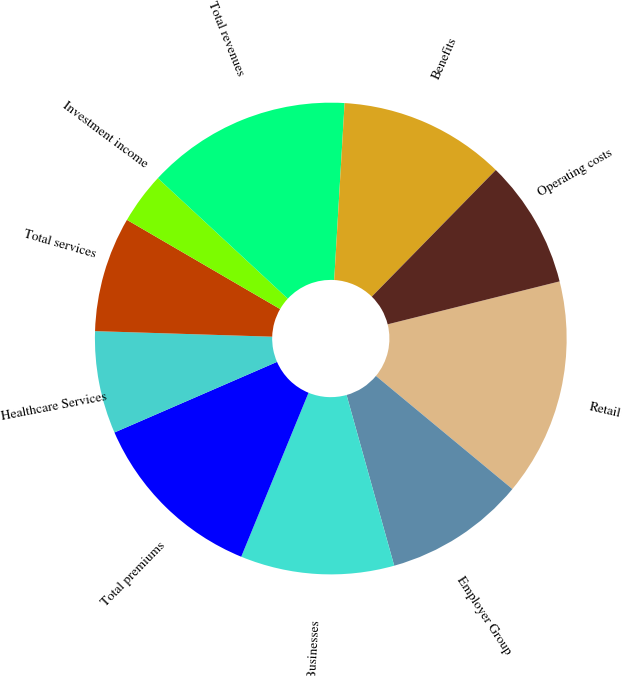Convert chart. <chart><loc_0><loc_0><loc_500><loc_500><pie_chart><fcel>Retail<fcel>Employer Group<fcel>Other Businesses<fcel>Total premiums<fcel>Healthcare Services<fcel>Total services<fcel>Investment income<fcel>Total revenues<fcel>Benefits<fcel>Operating costs<nl><fcel>14.91%<fcel>9.65%<fcel>10.53%<fcel>12.28%<fcel>7.02%<fcel>7.89%<fcel>3.51%<fcel>14.03%<fcel>11.4%<fcel>8.77%<nl></chart> 